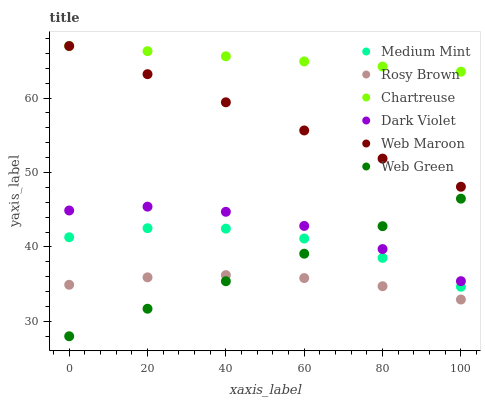Does Rosy Brown have the minimum area under the curve?
Answer yes or no. Yes. Does Chartreuse have the maximum area under the curve?
Answer yes or no. Yes. Does Web Maroon have the minimum area under the curve?
Answer yes or no. No. Does Web Maroon have the maximum area under the curve?
Answer yes or no. No. Is Web Green the smoothest?
Answer yes or no. Yes. Is Medium Mint the roughest?
Answer yes or no. Yes. Is Rosy Brown the smoothest?
Answer yes or no. No. Is Rosy Brown the roughest?
Answer yes or no. No. Does Web Green have the lowest value?
Answer yes or no. Yes. Does Rosy Brown have the lowest value?
Answer yes or no. No. Does Chartreuse have the highest value?
Answer yes or no. Yes. Does Rosy Brown have the highest value?
Answer yes or no. No. Is Medium Mint less than Dark Violet?
Answer yes or no. Yes. Is Web Maroon greater than Rosy Brown?
Answer yes or no. Yes. Does Medium Mint intersect Web Green?
Answer yes or no. Yes. Is Medium Mint less than Web Green?
Answer yes or no. No. Is Medium Mint greater than Web Green?
Answer yes or no. No. Does Medium Mint intersect Dark Violet?
Answer yes or no. No. 